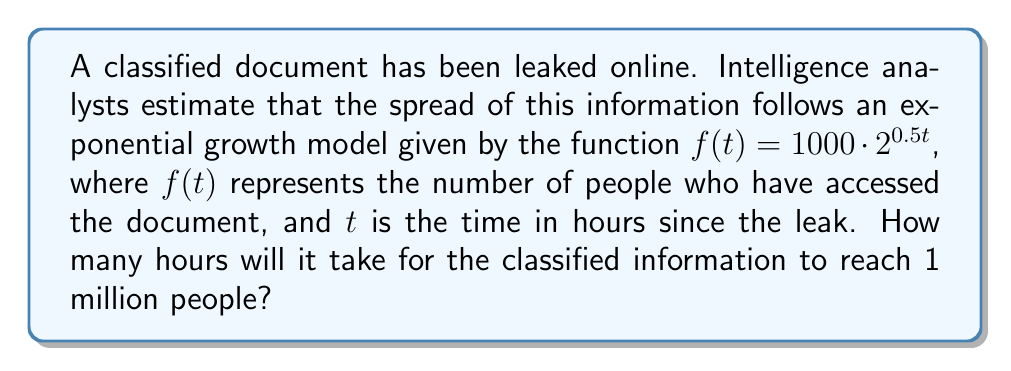Could you help me with this problem? To solve this problem, we need to find the value of $t$ when $f(t) = 1,000,000$. We can use the following steps:

1. Set up the equation:
   $1,000,000 = 1000 \cdot 2^{0.5t}$

2. Divide both sides by 1000:
   $1,000 = 2^{0.5t}$

3. Take the logarithm (base 2) of both sides:
   $\log_2(1,000) = \log_2(2^{0.5t})$

4. Using the logarithm property $\log_a(a^x) = x$, we get:
   $\log_2(1,000) = 0.5t$

5. Solve for $t$:
   $t = \frac{\log_2(1,000)}{0.5}$

6. Calculate the value:
   $t = \frac{\log_2(1,000)}{0.5} \approx 19.93$ hours

Therefore, it will take approximately 19.93 hours for the classified information to reach 1 million people.
Answer: 19.93 hours 